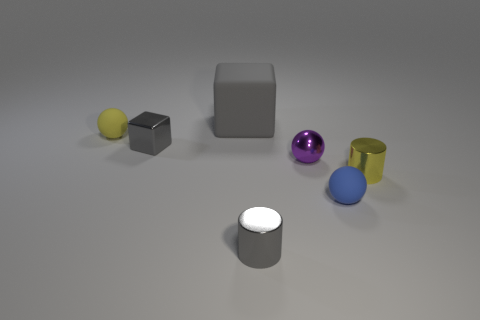Subtract all tiny matte spheres. How many spheres are left? 1 Subtract all spheres. How many objects are left? 4 Subtract all yellow cylinders. How many cylinders are left? 1 Subtract 1 gray cylinders. How many objects are left? 6 Subtract 1 spheres. How many spheres are left? 2 Subtract all gray spheres. Subtract all cyan cubes. How many spheres are left? 3 Subtract all blue cylinders. How many yellow spheres are left? 1 Subtract all large purple metal blocks. Subtract all purple metallic objects. How many objects are left? 6 Add 6 tiny blue rubber objects. How many tiny blue rubber objects are left? 7 Add 5 large cyan shiny balls. How many large cyan shiny balls exist? 5 